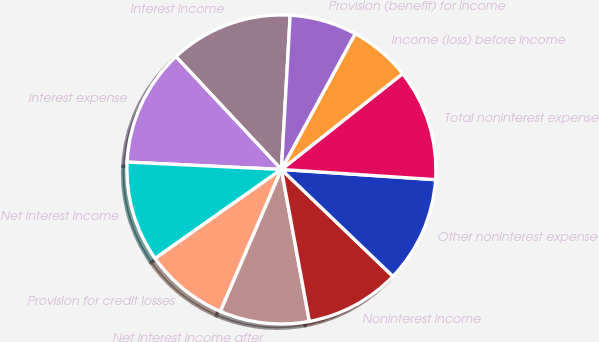Convert chart. <chart><loc_0><loc_0><loc_500><loc_500><pie_chart><fcel>Interest income<fcel>Interest expense<fcel>Net interest income<fcel>Provision for credit losses<fcel>Net interest income after<fcel>Noninterest income<fcel>Other noninterest expense<fcel>Total noninterest expense<fcel>Income (loss) before income<fcel>Provision (benefit) for income<nl><fcel>12.87%<fcel>12.28%<fcel>10.53%<fcel>8.77%<fcel>9.36%<fcel>9.94%<fcel>11.11%<fcel>11.7%<fcel>6.43%<fcel>7.02%<nl></chart> 